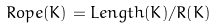<formula> <loc_0><loc_0><loc_500><loc_500>R o p e ( K ) = L e n g t h ( K ) / R ( K )</formula> 